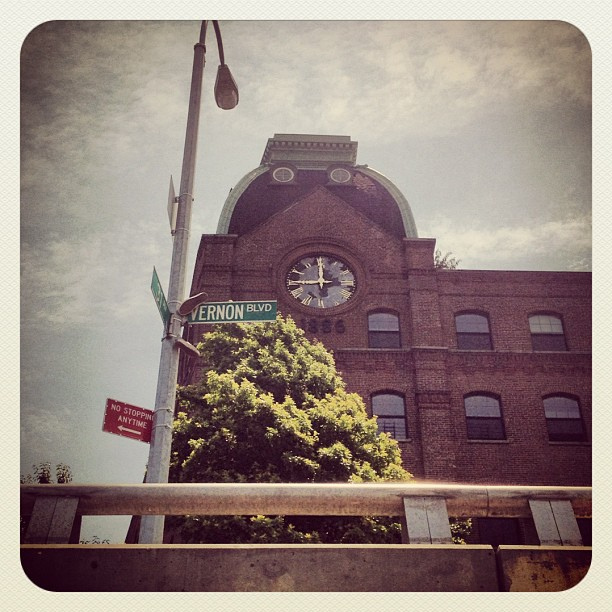Can you guess the age of this building based on its architecture? Based on the architectural style and the weathering on the bricks, it looks like it could be a late 19th to early 20th century structure, commonly seen in industrial areas during that era. 